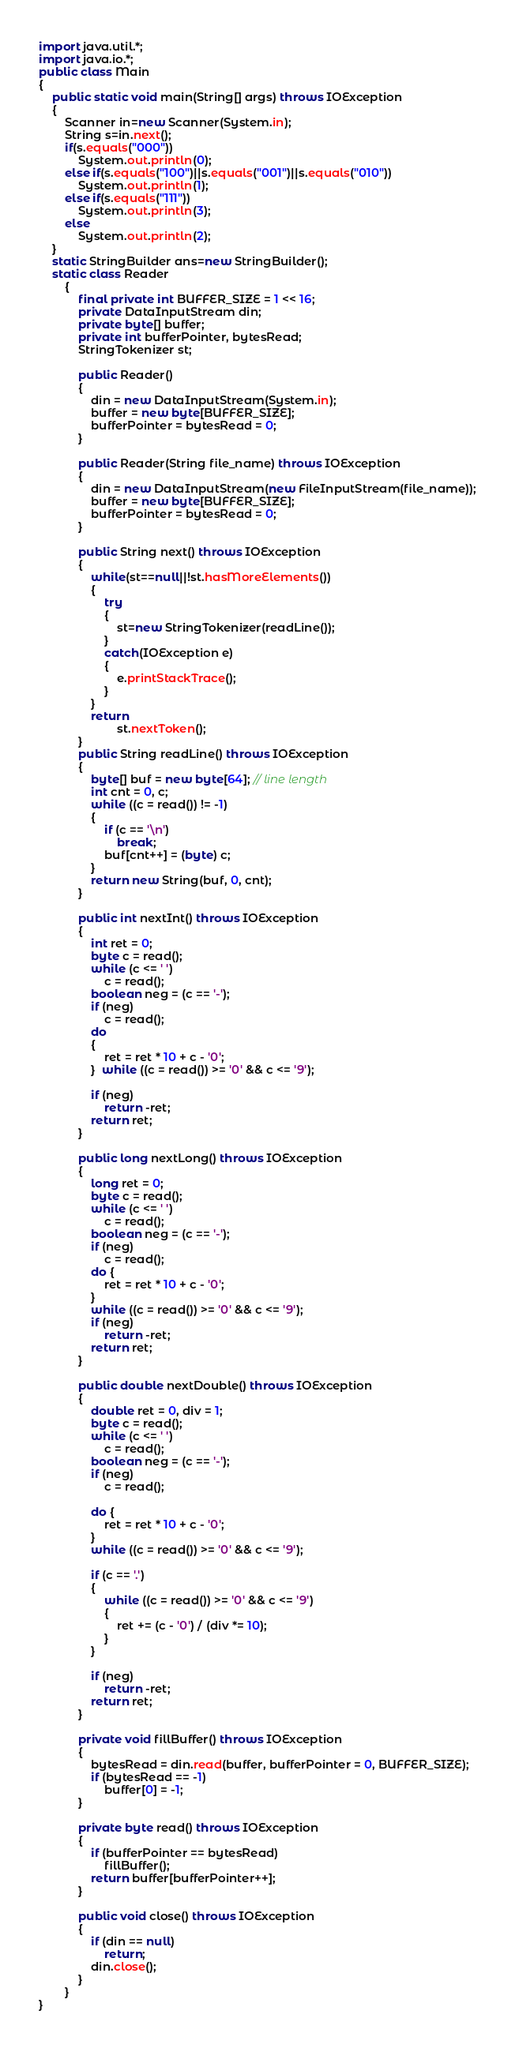<code> <loc_0><loc_0><loc_500><loc_500><_Java_>import java.util.*;
import java.io.*;
public class Main
{
	public static void main(String[] args) throws IOException
	{
		Scanner in=new Scanner(System.in);
		String s=in.next();
		if(s.equals("000"))
			System.out.println(0);
		else if(s.equals("100")||s.equals("001")||s.equals("010"))
			System.out.println(1);
		else if(s.equals("111"))
			System.out.println(3);
		else
			System.out.println(2);
	}
	static StringBuilder ans=new StringBuilder();
	static class Reader
	    {
	        final private int BUFFER_SIZE = 1 << 16;
	        private DataInputStream din;
	        private byte[] buffer;
	        private int bufferPointer, bytesRead;
	        StringTokenizer st;
	 
	        public Reader()
	        {
	            din = new DataInputStream(System.in);
	            buffer = new byte[BUFFER_SIZE];
	            bufferPointer = bytesRead = 0;
	        }
	 
	        public Reader(String file_name) throws IOException
	        {
	            din = new DataInputStream(new FileInputStream(file_name));
	            buffer = new byte[BUFFER_SIZE];
	            bufferPointer = bytesRead = 0;
	        }
	 
	        public String next() throws IOException
	        {
	        	while(st==null||!st.hasMoreElements())
	        	{
	        		try
	        		{
	        			st=new StringTokenizer(readLine());
	        		}
	        		catch(IOException e)
	        		{
	        			e.printStackTrace();
	        		}
	        	}
	        	return
	        			st.nextToken();
	        }
	        public String readLine() throws IOException
	        {
	            byte[] buf = new byte[64]; // line length
	            int cnt = 0, c;
	            while ((c = read()) != -1)
	            {
	                if (c == '\n')
	                    break;
	                buf[cnt++] = (byte) c;
	            }
	            return new String(buf, 0, cnt);
	        }
	 
	        public int nextInt() throws IOException
	        {
	            int ret = 0;
	            byte c = read();
	            while (c <= ' ')
	                c = read();
	            boolean neg = (c == '-');
	            if (neg)
	                c = read();
	            do
	            {
	                ret = ret * 10 + c - '0';
	            }  while ((c = read()) >= '0' && c <= '9');
	 
	            if (neg)
	                return -ret;
	            return ret;
	        }
	 
	        public long nextLong() throws IOException
	        {
	            long ret = 0;
	            byte c = read();
	            while (c <= ' ')
	                c = read();
	            boolean neg = (c == '-');
	            if (neg)
	                c = read();
	            do {
	                ret = ret * 10 + c - '0';
	            }
	            while ((c = read()) >= '0' && c <= '9');
	            if (neg)
	                return -ret;
	            return ret;
	        }
	 
	        public double nextDouble() throws IOException
	        {
	            double ret = 0, div = 1;
	            byte c = read();
	            while (c <= ' ')
	                c = read();
	            boolean neg = (c == '-');
	            if (neg)
	                c = read();
	 
	            do {
	                ret = ret * 10 + c - '0';
	            }
	            while ((c = read()) >= '0' && c <= '9');
	 
	            if (c == '.')
	            {
	                while ((c = read()) >= '0' && c <= '9')
	                {
	                    ret += (c - '0') / (div *= 10);
	                }
	            }
	 
	            if (neg)
	                return -ret;
	            return ret;
	        }
	 
	        private void fillBuffer() throws IOException
	        {
	            bytesRead = din.read(buffer, bufferPointer = 0, BUFFER_SIZE);
	            if (bytesRead == -1)
	                buffer[0] = -1;
	        }
	 
	        private byte read() throws IOException
	        {
	            if (bufferPointer == bytesRead)
	                fillBuffer();
	            return buffer[bufferPointer++];
	        }
	 
	        public void close() throws IOException
	        {
	            if (din == null)
	                return;
	            din.close();
	        }
	    }
}   </code> 